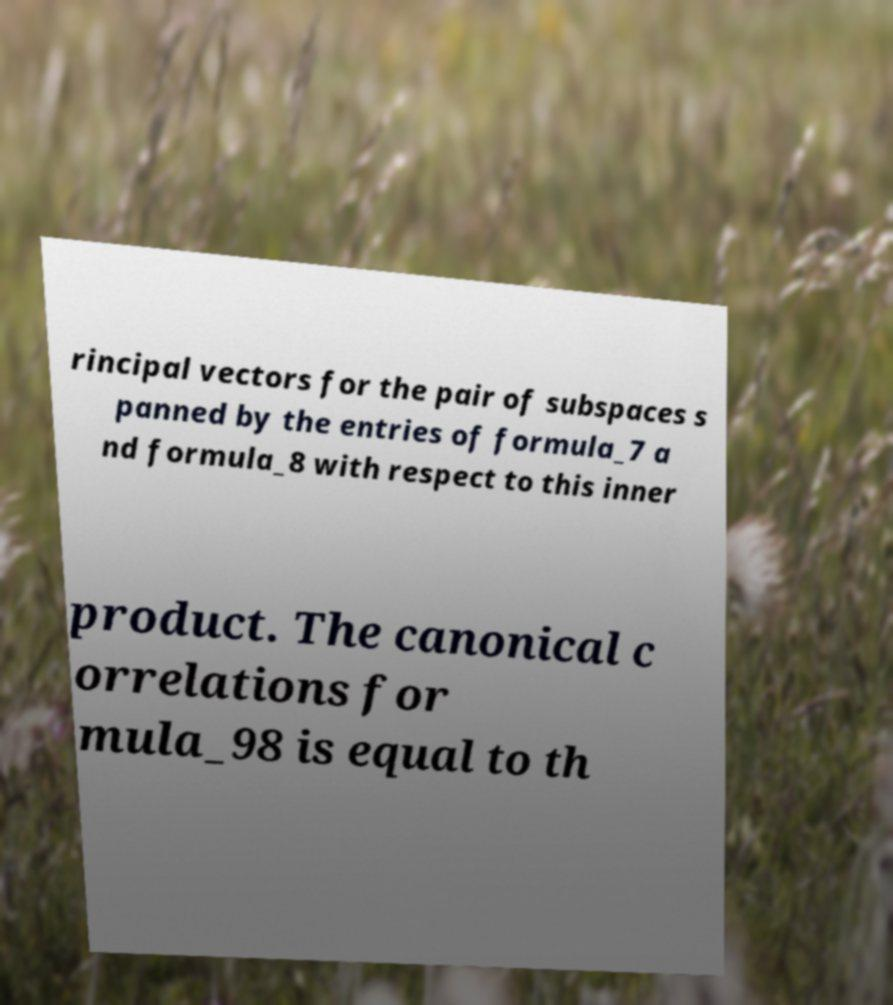For documentation purposes, I need the text within this image transcribed. Could you provide that? rincipal vectors for the pair of subspaces s panned by the entries of formula_7 a nd formula_8 with respect to this inner product. The canonical c orrelations for mula_98 is equal to th 